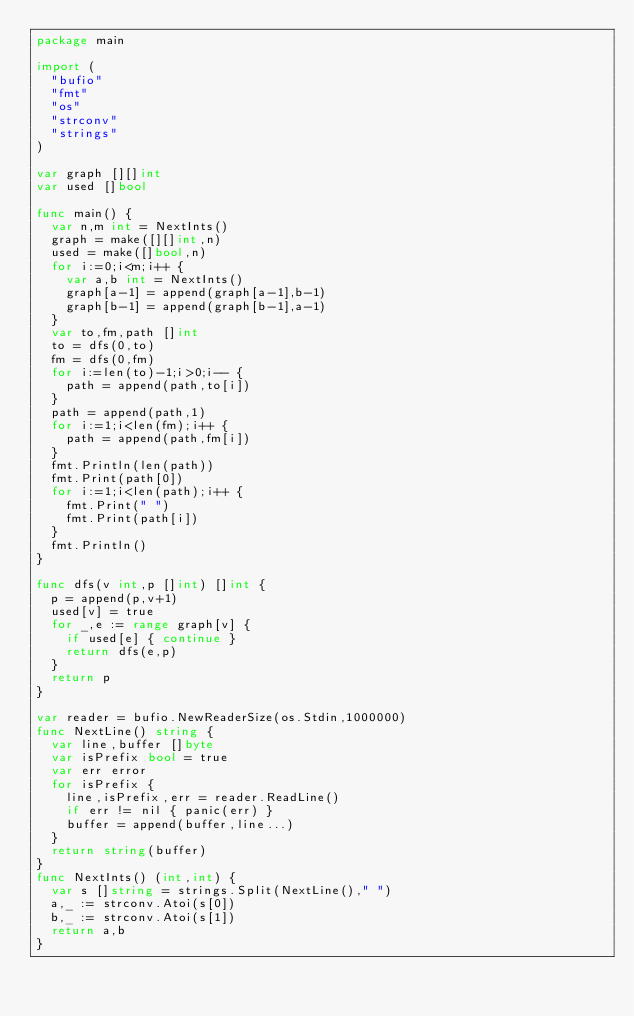Convert code to text. <code><loc_0><loc_0><loc_500><loc_500><_Go_>package main

import (
  "bufio"
  "fmt"
  "os"
  "strconv"
  "strings"
)

var graph [][]int
var used []bool

func main() {
  var n,m int = NextInts()
  graph = make([][]int,n)
  used = make([]bool,n)
  for i:=0;i<m;i++ {
    var a,b int = NextInts()
    graph[a-1] = append(graph[a-1],b-1)
    graph[b-1] = append(graph[b-1],a-1)
  }
  var to,fm,path []int
  to = dfs(0,to)
  fm = dfs(0,fm)
  for i:=len(to)-1;i>0;i-- {
    path = append(path,to[i])
  }
  path = append(path,1)
  for i:=1;i<len(fm);i++ {
    path = append(path,fm[i])
  }
  fmt.Println(len(path))
  fmt.Print(path[0])
  for i:=1;i<len(path);i++ {
    fmt.Print(" ")
    fmt.Print(path[i])
  }
  fmt.Println()
}

func dfs(v int,p []int) []int {
  p = append(p,v+1)
  used[v] = true
  for _,e := range graph[v] {
    if used[e] { continue }
    return dfs(e,p)
  }
  return p
}

var reader = bufio.NewReaderSize(os.Stdin,1000000)
func NextLine() string {
  var line,buffer []byte
  var isPrefix bool = true
  var err error
  for isPrefix {
    line,isPrefix,err = reader.ReadLine()
    if err != nil { panic(err) }
    buffer = append(buffer,line...)
  }
  return string(buffer)
}
func NextInts() (int,int) {
  var s []string = strings.Split(NextLine()," ")
  a,_ := strconv.Atoi(s[0])
  b,_ := strconv.Atoi(s[1])
  return a,b
}</code> 